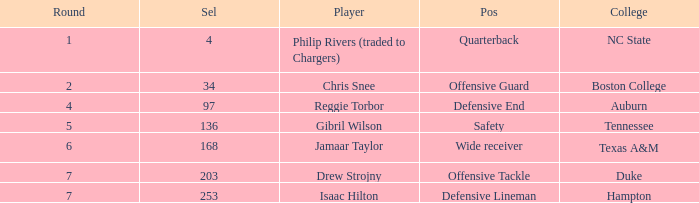Which Position has a Player of gibril wilson? Safety. 